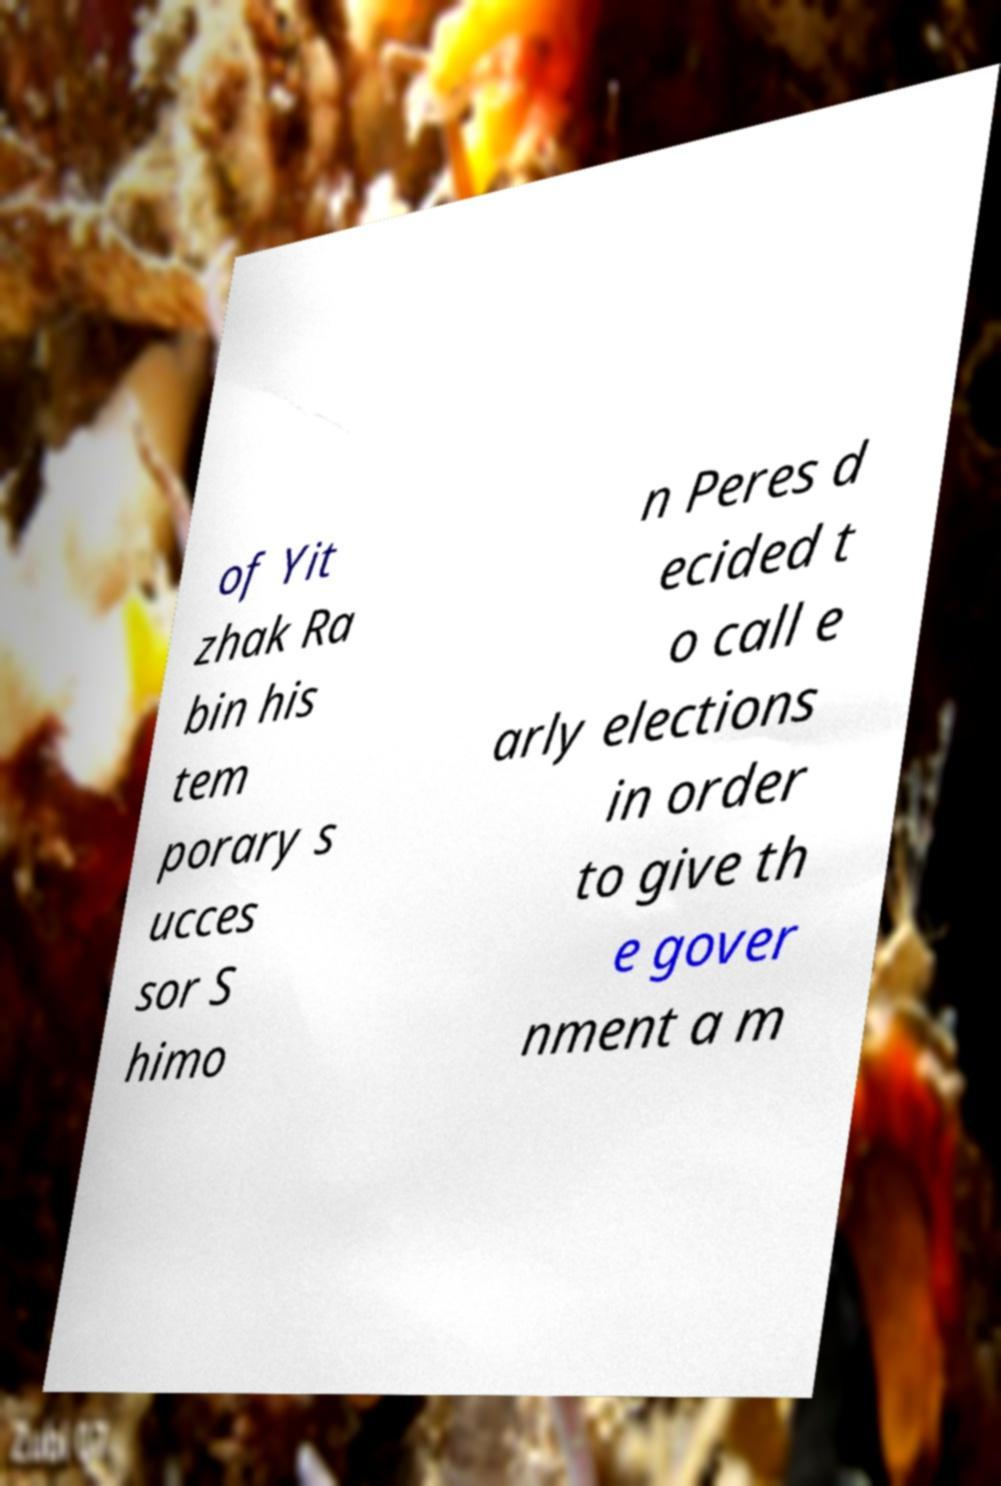Can you accurately transcribe the text from the provided image for me? of Yit zhak Ra bin his tem porary s ucces sor S himo n Peres d ecided t o call e arly elections in order to give th e gover nment a m 